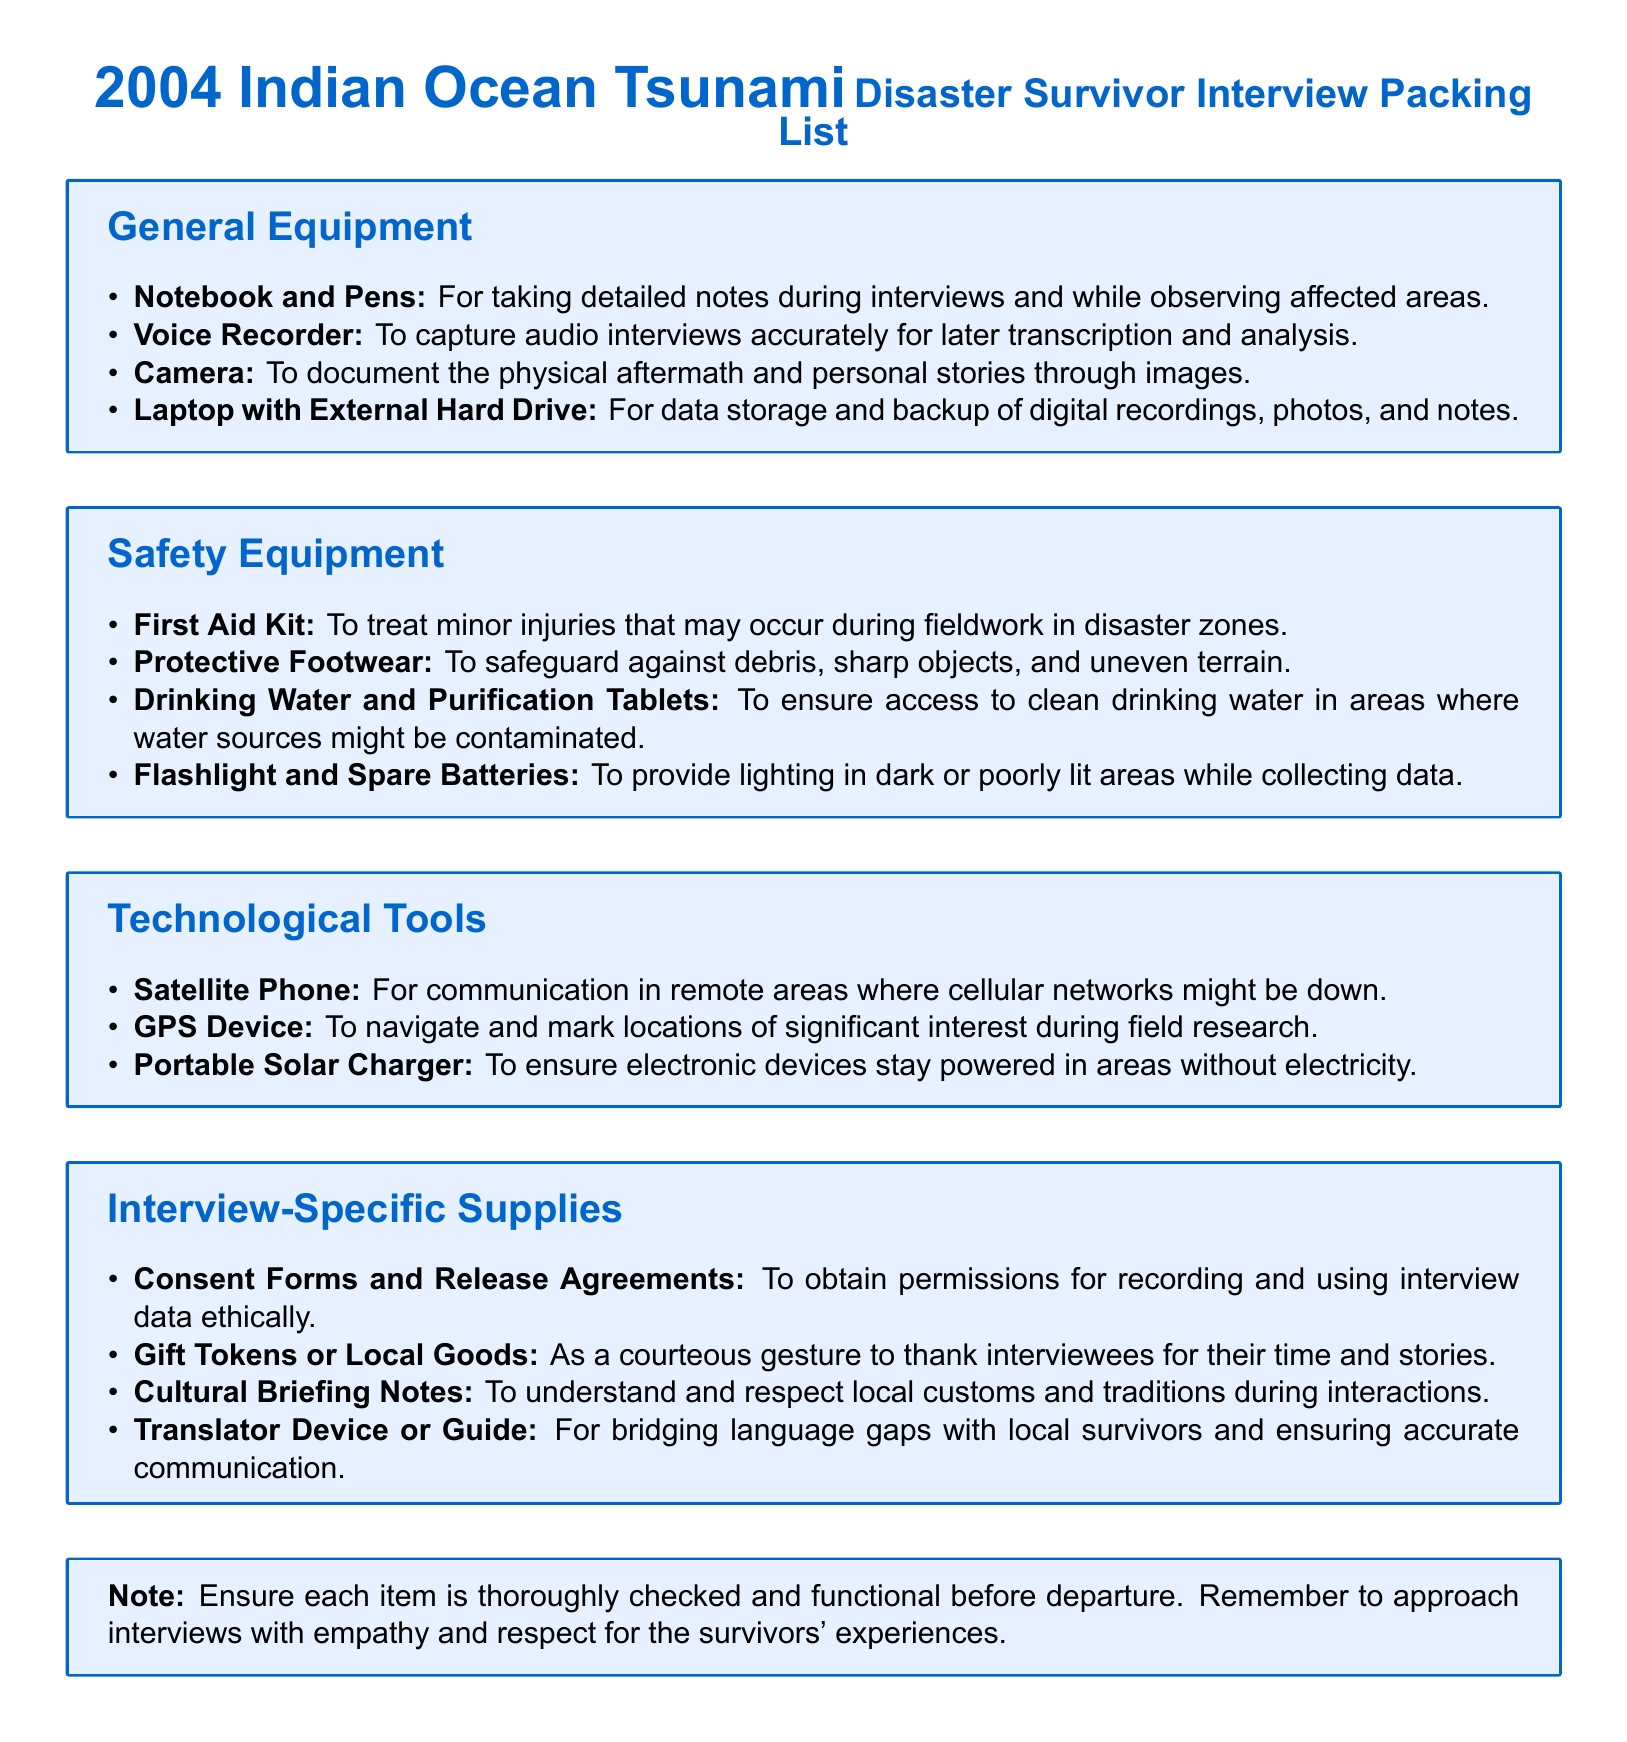what is the title of the document? The title of the document is prominently displayed at the top and is "2004 Indian Ocean Tsunami Disaster Survivor Interview Packing List."
Answer: 2004 Indian Ocean Tsunami Disaster Survivor Interview Packing List what item is used to document physical aftermath? This item is specifically mentioned in the 'General Equipment' section for capturing images of the disaster.
Answer: Camera how many categories of equipment are listed? The document organizes the equipment into four distinct categories, making it clear and easy to navigate.
Answer: 4 what is the purpose of the First Aid Kit? The First Aid Kit is included for attending to minor injuries that may occur while working in the disaster zone.
Answer: To treat minor injuries what item ensures communication in remote areas? This item allows for staying connected even when cellular networks may be out of service, highlighted under 'Technological Tools.'
Answer: Satellite Phone what type of items are 'Consent Forms and Release Agreements'? These items are categorized under 'Interview-Specific Supplies' for ethical considerations during interviews.
Answer: Interview-Specific Supplies why are cultural briefing notes included in the packing list? Cultural briefing notes are vital for understanding and respecting local customs, thereby facilitating better interactions during interviews.
Answer: To understand and respect local customs what equipment is essential for data backup? This equipment helps in securely storing and ensuring the availability of digital data collected during the fieldwork.
Answer: Laptop with External Hard Drive 